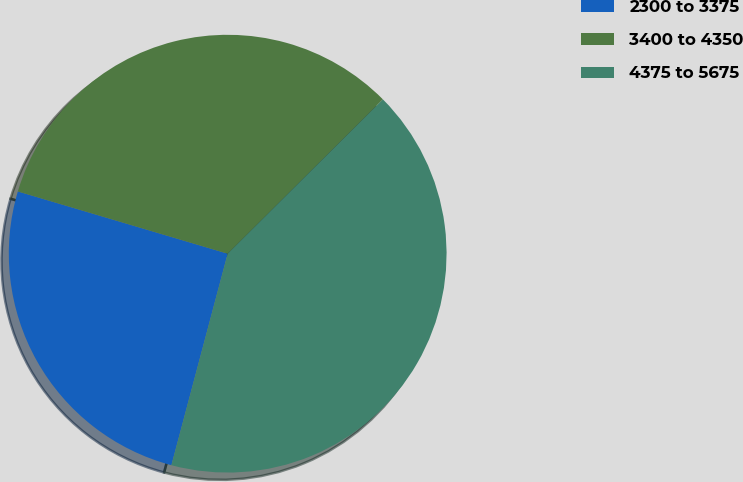Convert chart. <chart><loc_0><loc_0><loc_500><loc_500><pie_chart><fcel>2300 to 3375<fcel>3400 to 4350<fcel>4375 to 5675<nl><fcel>25.45%<fcel>32.96%<fcel>41.59%<nl></chart> 